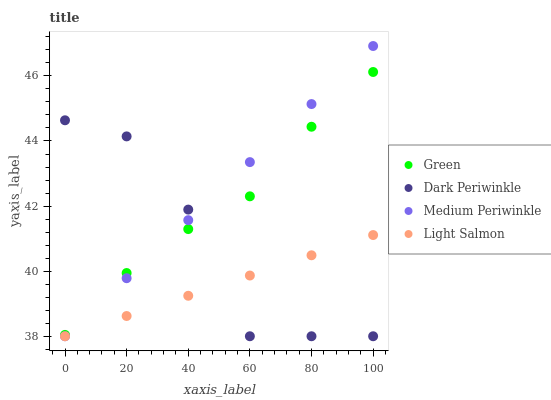Does Light Salmon have the minimum area under the curve?
Answer yes or no. Yes. Does Medium Periwinkle have the maximum area under the curve?
Answer yes or no. Yes. Does Green have the minimum area under the curve?
Answer yes or no. No. Does Green have the maximum area under the curve?
Answer yes or no. No. Is Light Salmon the smoothest?
Answer yes or no. Yes. Is Dark Periwinkle the roughest?
Answer yes or no. Yes. Is Green the smoothest?
Answer yes or no. No. Is Green the roughest?
Answer yes or no. No. Does Medium Periwinkle have the lowest value?
Answer yes or no. Yes. Does Green have the lowest value?
Answer yes or no. No. Does Medium Periwinkle have the highest value?
Answer yes or no. Yes. Does Green have the highest value?
Answer yes or no. No. Is Light Salmon less than Green?
Answer yes or no. Yes. Is Green greater than Light Salmon?
Answer yes or no. Yes. Does Dark Periwinkle intersect Light Salmon?
Answer yes or no. Yes. Is Dark Periwinkle less than Light Salmon?
Answer yes or no. No. Is Dark Periwinkle greater than Light Salmon?
Answer yes or no. No. Does Light Salmon intersect Green?
Answer yes or no. No. 